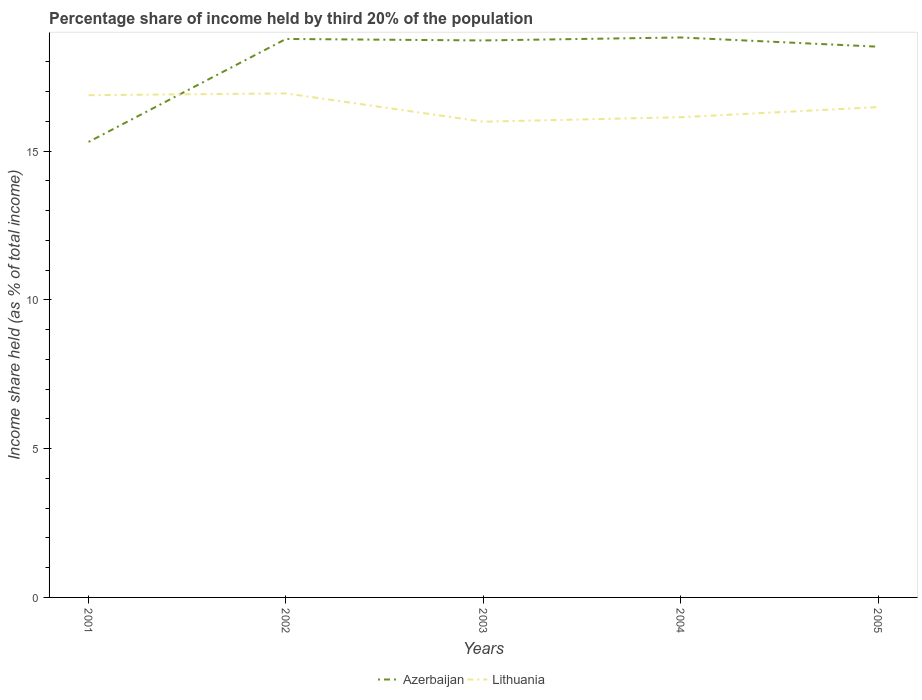Does the line corresponding to Azerbaijan intersect with the line corresponding to Lithuania?
Offer a terse response. Yes. Is the number of lines equal to the number of legend labels?
Your answer should be very brief. Yes. Across all years, what is the maximum share of income held by third 20% of the population in Lithuania?
Your response must be concise. 15.99. What is the total share of income held by third 20% of the population in Azerbaijan in the graph?
Ensure brevity in your answer.  0.05. What is the difference between the highest and the second highest share of income held by third 20% of the population in Lithuania?
Give a very brief answer. 0.95. What is the difference between the highest and the lowest share of income held by third 20% of the population in Lithuania?
Your response must be concise. 2. How many lines are there?
Offer a very short reply. 2. What is the difference between two consecutive major ticks on the Y-axis?
Make the answer very short. 5. Are the values on the major ticks of Y-axis written in scientific E-notation?
Give a very brief answer. No. How are the legend labels stacked?
Provide a succinct answer. Horizontal. What is the title of the graph?
Give a very brief answer. Percentage share of income held by third 20% of the population. Does "Rwanda" appear as one of the legend labels in the graph?
Offer a very short reply. No. What is the label or title of the Y-axis?
Your response must be concise. Income share held (as % of total income). What is the Income share held (as % of total income) of Azerbaijan in 2001?
Keep it short and to the point. 15.31. What is the Income share held (as % of total income) in Lithuania in 2001?
Your answer should be very brief. 16.88. What is the Income share held (as % of total income) in Azerbaijan in 2002?
Provide a short and direct response. 18.77. What is the Income share held (as % of total income) in Lithuania in 2002?
Offer a very short reply. 16.94. What is the Income share held (as % of total income) in Azerbaijan in 2003?
Your answer should be compact. 18.72. What is the Income share held (as % of total income) of Lithuania in 2003?
Your answer should be compact. 15.99. What is the Income share held (as % of total income) of Azerbaijan in 2004?
Offer a very short reply. 18.82. What is the Income share held (as % of total income) in Lithuania in 2004?
Your answer should be very brief. 16.14. What is the Income share held (as % of total income) of Azerbaijan in 2005?
Offer a very short reply. 18.51. What is the Income share held (as % of total income) in Lithuania in 2005?
Ensure brevity in your answer.  16.48. Across all years, what is the maximum Income share held (as % of total income) in Azerbaijan?
Offer a very short reply. 18.82. Across all years, what is the maximum Income share held (as % of total income) in Lithuania?
Give a very brief answer. 16.94. Across all years, what is the minimum Income share held (as % of total income) of Azerbaijan?
Keep it short and to the point. 15.31. Across all years, what is the minimum Income share held (as % of total income) in Lithuania?
Offer a very short reply. 15.99. What is the total Income share held (as % of total income) of Azerbaijan in the graph?
Your response must be concise. 90.13. What is the total Income share held (as % of total income) in Lithuania in the graph?
Keep it short and to the point. 82.43. What is the difference between the Income share held (as % of total income) in Azerbaijan in 2001 and that in 2002?
Provide a short and direct response. -3.46. What is the difference between the Income share held (as % of total income) in Lithuania in 2001 and that in 2002?
Make the answer very short. -0.06. What is the difference between the Income share held (as % of total income) in Azerbaijan in 2001 and that in 2003?
Your answer should be compact. -3.41. What is the difference between the Income share held (as % of total income) in Lithuania in 2001 and that in 2003?
Offer a terse response. 0.89. What is the difference between the Income share held (as % of total income) of Azerbaijan in 2001 and that in 2004?
Provide a succinct answer. -3.51. What is the difference between the Income share held (as % of total income) of Lithuania in 2001 and that in 2004?
Keep it short and to the point. 0.74. What is the difference between the Income share held (as % of total income) in Azerbaijan in 2001 and that in 2005?
Offer a terse response. -3.2. What is the difference between the Income share held (as % of total income) of Lithuania in 2001 and that in 2005?
Your answer should be compact. 0.4. What is the difference between the Income share held (as % of total income) in Azerbaijan in 2002 and that in 2003?
Provide a short and direct response. 0.05. What is the difference between the Income share held (as % of total income) of Lithuania in 2002 and that in 2004?
Keep it short and to the point. 0.8. What is the difference between the Income share held (as % of total income) in Azerbaijan in 2002 and that in 2005?
Your response must be concise. 0.26. What is the difference between the Income share held (as % of total income) of Lithuania in 2002 and that in 2005?
Make the answer very short. 0.46. What is the difference between the Income share held (as % of total income) of Azerbaijan in 2003 and that in 2004?
Offer a very short reply. -0.1. What is the difference between the Income share held (as % of total income) of Azerbaijan in 2003 and that in 2005?
Keep it short and to the point. 0.21. What is the difference between the Income share held (as % of total income) in Lithuania in 2003 and that in 2005?
Offer a very short reply. -0.49. What is the difference between the Income share held (as % of total income) of Azerbaijan in 2004 and that in 2005?
Your answer should be compact. 0.31. What is the difference between the Income share held (as % of total income) of Lithuania in 2004 and that in 2005?
Provide a succinct answer. -0.34. What is the difference between the Income share held (as % of total income) in Azerbaijan in 2001 and the Income share held (as % of total income) in Lithuania in 2002?
Provide a succinct answer. -1.63. What is the difference between the Income share held (as % of total income) in Azerbaijan in 2001 and the Income share held (as % of total income) in Lithuania in 2003?
Offer a terse response. -0.68. What is the difference between the Income share held (as % of total income) in Azerbaijan in 2001 and the Income share held (as % of total income) in Lithuania in 2004?
Provide a succinct answer. -0.83. What is the difference between the Income share held (as % of total income) in Azerbaijan in 2001 and the Income share held (as % of total income) in Lithuania in 2005?
Your answer should be very brief. -1.17. What is the difference between the Income share held (as % of total income) of Azerbaijan in 2002 and the Income share held (as % of total income) of Lithuania in 2003?
Offer a very short reply. 2.78. What is the difference between the Income share held (as % of total income) in Azerbaijan in 2002 and the Income share held (as % of total income) in Lithuania in 2004?
Provide a short and direct response. 2.63. What is the difference between the Income share held (as % of total income) of Azerbaijan in 2002 and the Income share held (as % of total income) of Lithuania in 2005?
Give a very brief answer. 2.29. What is the difference between the Income share held (as % of total income) of Azerbaijan in 2003 and the Income share held (as % of total income) of Lithuania in 2004?
Your response must be concise. 2.58. What is the difference between the Income share held (as % of total income) in Azerbaijan in 2003 and the Income share held (as % of total income) in Lithuania in 2005?
Your answer should be very brief. 2.24. What is the difference between the Income share held (as % of total income) in Azerbaijan in 2004 and the Income share held (as % of total income) in Lithuania in 2005?
Your response must be concise. 2.34. What is the average Income share held (as % of total income) in Azerbaijan per year?
Keep it short and to the point. 18.03. What is the average Income share held (as % of total income) of Lithuania per year?
Give a very brief answer. 16.49. In the year 2001, what is the difference between the Income share held (as % of total income) of Azerbaijan and Income share held (as % of total income) of Lithuania?
Offer a terse response. -1.57. In the year 2002, what is the difference between the Income share held (as % of total income) in Azerbaijan and Income share held (as % of total income) in Lithuania?
Give a very brief answer. 1.83. In the year 2003, what is the difference between the Income share held (as % of total income) of Azerbaijan and Income share held (as % of total income) of Lithuania?
Make the answer very short. 2.73. In the year 2004, what is the difference between the Income share held (as % of total income) of Azerbaijan and Income share held (as % of total income) of Lithuania?
Make the answer very short. 2.68. In the year 2005, what is the difference between the Income share held (as % of total income) in Azerbaijan and Income share held (as % of total income) in Lithuania?
Provide a short and direct response. 2.03. What is the ratio of the Income share held (as % of total income) of Azerbaijan in 2001 to that in 2002?
Provide a short and direct response. 0.82. What is the ratio of the Income share held (as % of total income) of Azerbaijan in 2001 to that in 2003?
Keep it short and to the point. 0.82. What is the ratio of the Income share held (as % of total income) of Lithuania in 2001 to that in 2003?
Your answer should be very brief. 1.06. What is the ratio of the Income share held (as % of total income) of Azerbaijan in 2001 to that in 2004?
Your answer should be very brief. 0.81. What is the ratio of the Income share held (as % of total income) in Lithuania in 2001 to that in 2004?
Offer a very short reply. 1.05. What is the ratio of the Income share held (as % of total income) of Azerbaijan in 2001 to that in 2005?
Ensure brevity in your answer.  0.83. What is the ratio of the Income share held (as % of total income) of Lithuania in 2001 to that in 2005?
Offer a very short reply. 1.02. What is the ratio of the Income share held (as % of total income) of Lithuania in 2002 to that in 2003?
Ensure brevity in your answer.  1.06. What is the ratio of the Income share held (as % of total income) of Lithuania in 2002 to that in 2004?
Provide a short and direct response. 1.05. What is the ratio of the Income share held (as % of total income) of Azerbaijan in 2002 to that in 2005?
Ensure brevity in your answer.  1.01. What is the ratio of the Income share held (as % of total income) of Lithuania in 2002 to that in 2005?
Keep it short and to the point. 1.03. What is the ratio of the Income share held (as % of total income) in Lithuania in 2003 to that in 2004?
Your answer should be compact. 0.99. What is the ratio of the Income share held (as % of total income) in Azerbaijan in 2003 to that in 2005?
Give a very brief answer. 1.01. What is the ratio of the Income share held (as % of total income) of Lithuania in 2003 to that in 2005?
Provide a succinct answer. 0.97. What is the ratio of the Income share held (as % of total income) in Azerbaijan in 2004 to that in 2005?
Your answer should be compact. 1.02. What is the ratio of the Income share held (as % of total income) of Lithuania in 2004 to that in 2005?
Your response must be concise. 0.98. What is the difference between the highest and the second highest Income share held (as % of total income) of Azerbaijan?
Keep it short and to the point. 0.05. What is the difference between the highest and the second highest Income share held (as % of total income) of Lithuania?
Make the answer very short. 0.06. What is the difference between the highest and the lowest Income share held (as % of total income) of Azerbaijan?
Make the answer very short. 3.51. What is the difference between the highest and the lowest Income share held (as % of total income) in Lithuania?
Ensure brevity in your answer.  0.95. 